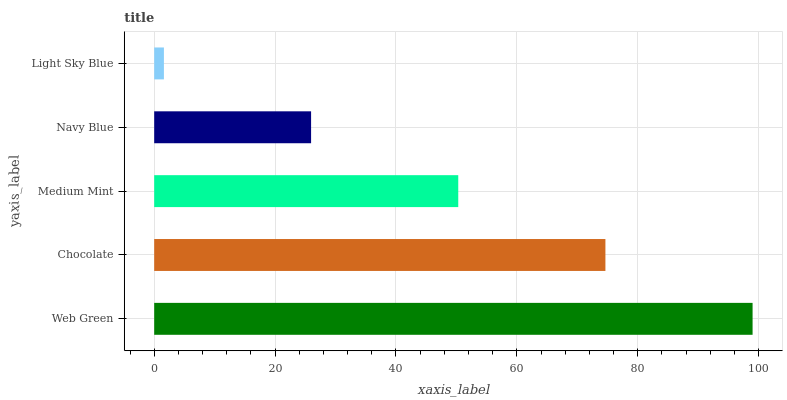Is Light Sky Blue the minimum?
Answer yes or no. Yes. Is Web Green the maximum?
Answer yes or no. Yes. Is Chocolate the minimum?
Answer yes or no. No. Is Chocolate the maximum?
Answer yes or no. No. Is Web Green greater than Chocolate?
Answer yes or no. Yes. Is Chocolate less than Web Green?
Answer yes or no. Yes. Is Chocolate greater than Web Green?
Answer yes or no. No. Is Web Green less than Chocolate?
Answer yes or no. No. Is Medium Mint the high median?
Answer yes or no. Yes. Is Medium Mint the low median?
Answer yes or no. Yes. Is Web Green the high median?
Answer yes or no. No. Is Light Sky Blue the low median?
Answer yes or no. No. 